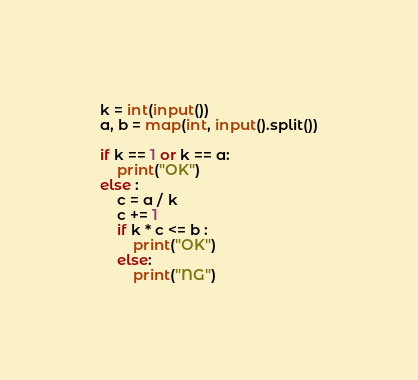Convert code to text. <code><loc_0><loc_0><loc_500><loc_500><_Python_>k = int(input())
a, b = map(int, input().split())

if k == 1 or k == a:
    print("OK")
else :
    c = a / k
    c += 1
    if k * c <= b :
        print("OK")
    else:
        print("NG")
</code> 